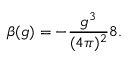Convert formula to latex. <formula><loc_0><loc_0><loc_500><loc_500>\beta ( g ) = - \frac { g ^ { 3 } } { ( 4 \pi ) ^ { 2 } } 8 .</formula> 